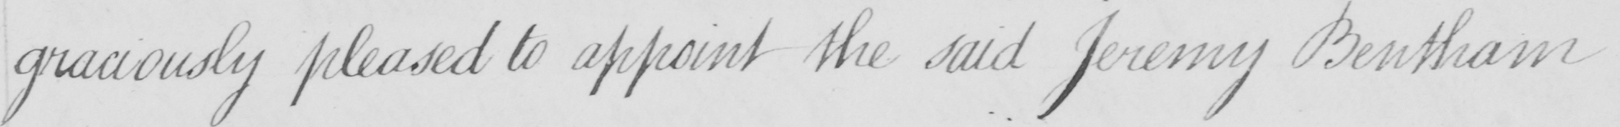What is written in this line of handwriting? graciously pleased to appoint the said Jeremy Bentham 